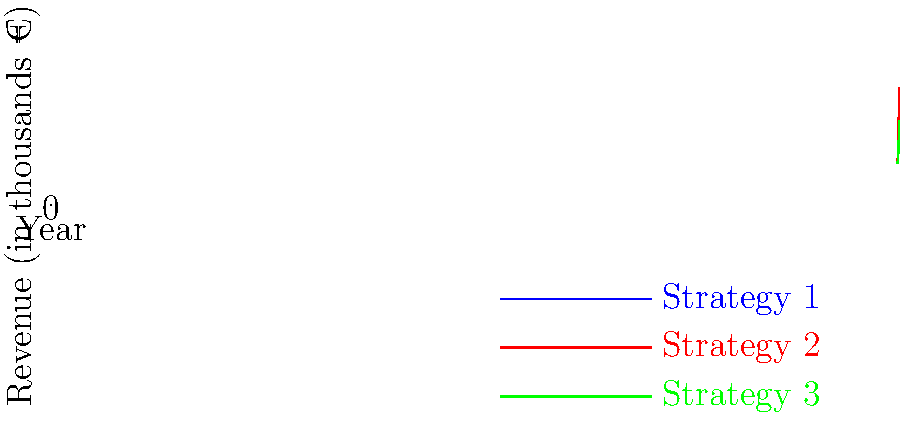Based on the line graph showing revenue growth projections for three different strategies, which strategy is projected to generate the highest revenue by 2027, and what is the estimated difference in revenue between the best and worst-performing strategies in that year? To answer this question, we need to follow these steps:

1. Identify the highest point on the graph for 2027:
   - Strategy 1: 240,000 €
   - Strategy 2: 280,000 €
   - Strategy 3: 200,000 €

   Strategy 2 (red line) has the highest point, so it's projected to generate the highest revenue by 2027.

2. Calculate the difference between the highest and lowest revenues in 2027:
   - Highest (Strategy 2): 280,000 €
   - Lowest (Strategy 3): 200,000 €
   - Difference: 280,000 € - 200,000 € = 80,000 €

Therefore, Strategy 2 is projected to generate the highest revenue by 2027, and the estimated difference in revenue between the best (Strategy 2) and worst-performing (Strategy 3) strategies in that year is 80,000 €.
Answer: Strategy 2; 80,000 € 